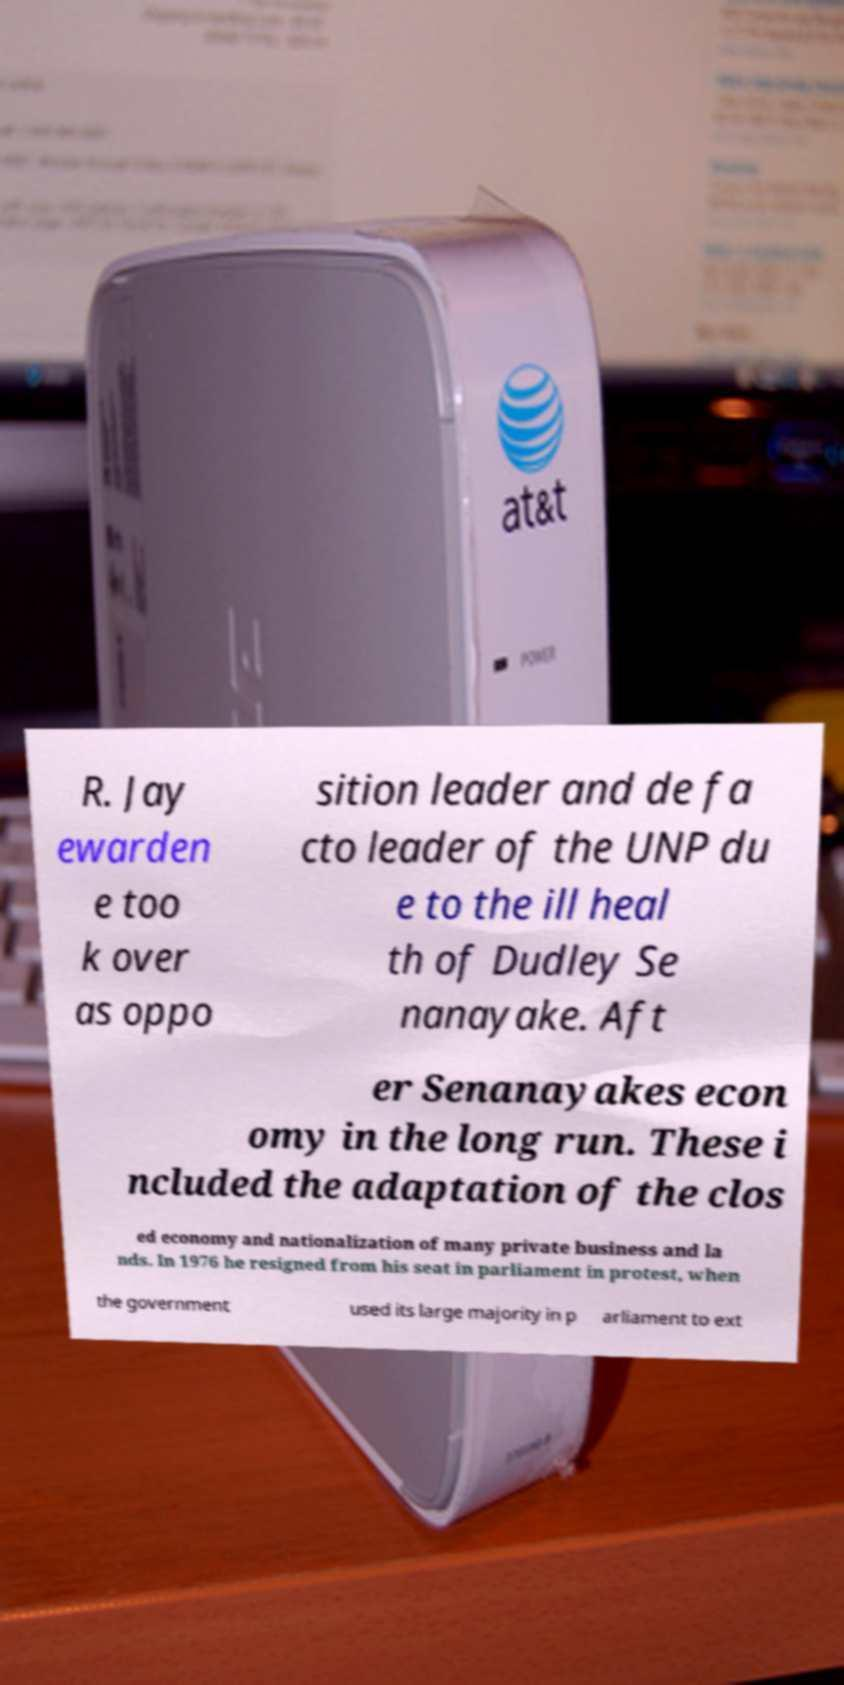Could you extract and type out the text from this image? R. Jay ewarden e too k over as oppo sition leader and de fa cto leader of the UNP du e to the ill heal th of Dudley Se nanayake. Aft er Senanayakes econ omy in the long run. These i ncluded the adaptation of the clos ed economy and nationalization of many private business and la nds. In 1976 he resigned from his seat in parliament in protest, when the government used its large majority in p arliament to ext 